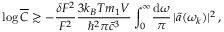<formula> <loc_0><loc_0><loc_500><loc_500>\log \overline { C } \gtrsim - \frac { \delta F ^ { 2 } } { F ^ { 2 } } \frac { 3 k _ { B } T m _ { 1 } V } { \hbar { ^ } { 2 } \pi \bar { c } ^ { 3 } } \int _ { 0 } ^ { \infty } \, \frac { d \omega } { \pi } \, | \tilde { a } ( \omega _ { k } ) | ^ { 2 } \, ,</formula> 